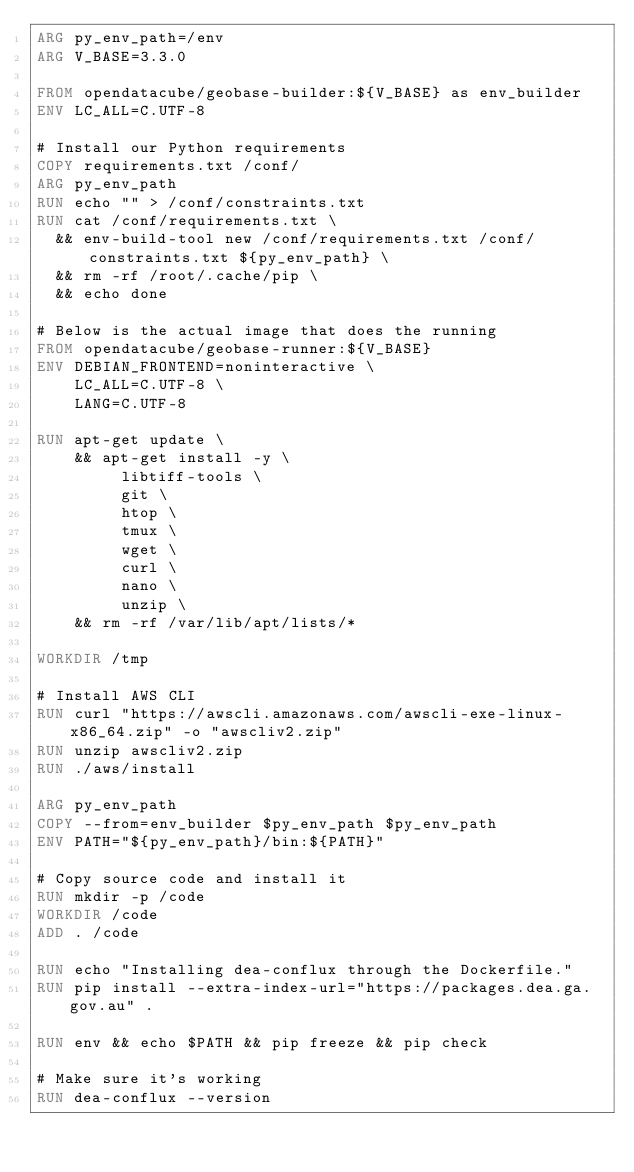<code> <loc_0><loc_0><loc_500><loc_500><_Dockerfile_>ARG py_env_path=/env
ARG V_BASE=3.3.0

FROM opendatacube/geobase-builder:${V_BASE} as env_builder
ENV LC_ALL=C.UTF-8

# Install our Python requirements
COPY requirements.txt /conf/
ARG py_env_path
RUN echo "" > /conf/constraints.txt
RUN cat /conf/requirements.txt \
  && env-build-tool new /conf/requirements.txt /conf/constraints.txt ${py_env_path} \
  && rm -rf /root/.cache/pip \
  && echo done

# Below is the actual image that does the running
FROM opendatacube/geobase-runner:${V_BASE}
ENV DEBIAN_FRONTEND=noninteractive \
    LC_ALL=C.UTF-8 \
    LANG=C.UTF-8
    
RUN apt-get update \
    && apt-get install -y \
         libtiff-tools \
         git \
         htop \
         tmux \
         wget \
         curl \
         nano \
         unzip \
    && rm -rf /var/lib/apt/lists/*

WORKDIR /tmp

# Install AWS CLI
RUN curl "https://awscli.amazonaws.com/awscli-exe-linux-x86_64.zip" -o "awscliv2.zip"
RUN unzip awscliv2.zip
RUN ./aws/install

ARG py_env_path
COPY --from=env_builder $py_env_path $py_env_path
ENV PATH="${py_env_path}/bin:${PATH}"

# Copy source code and install it
RUN mkdir -p /code
WORKDIR /code
ADD . /code

RUN echo "Installing dea-conflux through the Dockerfile."
RUN pip install --extra-index-url="https://packages.dea.ga.gov.au" .

RUN env && echo $PATH && pip freeze && pip check

# Make sure it's working
RUN dea-conflux --version
</code> 